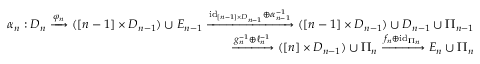Convert formula to latex. <formula><loc_0><loc_0><loc_500><loc_500>\begin{array} { r } { \alpha _ { n } \colon D _ { n } \xrightarrow { \varphi _ { n } } ( [ n - 1 ] \times D _ { n - 1 } ) \cup E _ { n - 1 } \xrightarrow { i d _ { [ n - 1 ] \times D _ { n - 1 } } \oplus \alpha _ { n - 1 } ^ { - 1 } } ( [ n - 1 ] \times D _ { n - 1 } ) \cup D _ { n - 1 } \cup \Pi _ { n - 1 } } \\ { \xrightarrow { g _ { n } ^ { - 1 } \oplus \ell _ { n } ^ { - 1 } } ( [ n ] \times D _ { n - 1 } ) \cup \Pi _ { n } \xrightarrow { f _ { n } \oplus i d _ { \Pi _ { n } } } E _ { n } \cup \Pi _ { n } } \end{array}</formula> 